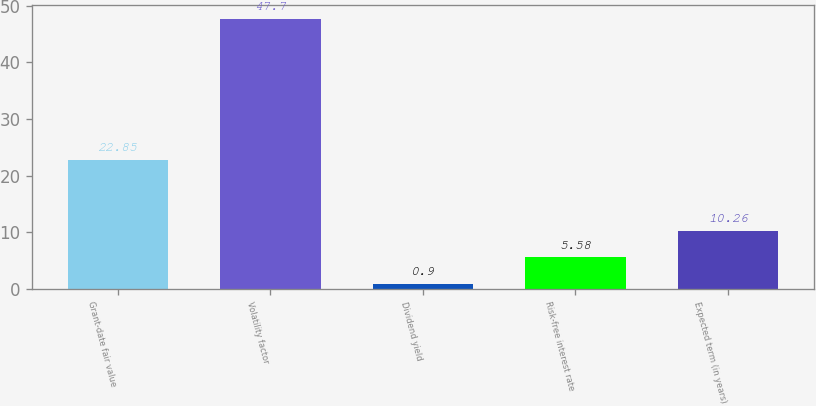Convert chart. <chart><loc_0><loc_0><loc_500><loc_500><bar_chart><fcel>Grant-date fair value<fcel>Volatility factor<fcel>Dividend yield<fcel>Risk-free interest rate<fcel>Expected term (in years)<nl><fcel>22.85<fcel>47.7<fcel>0.9<fcel>5.58<fcel>10.26<nl></chart> 